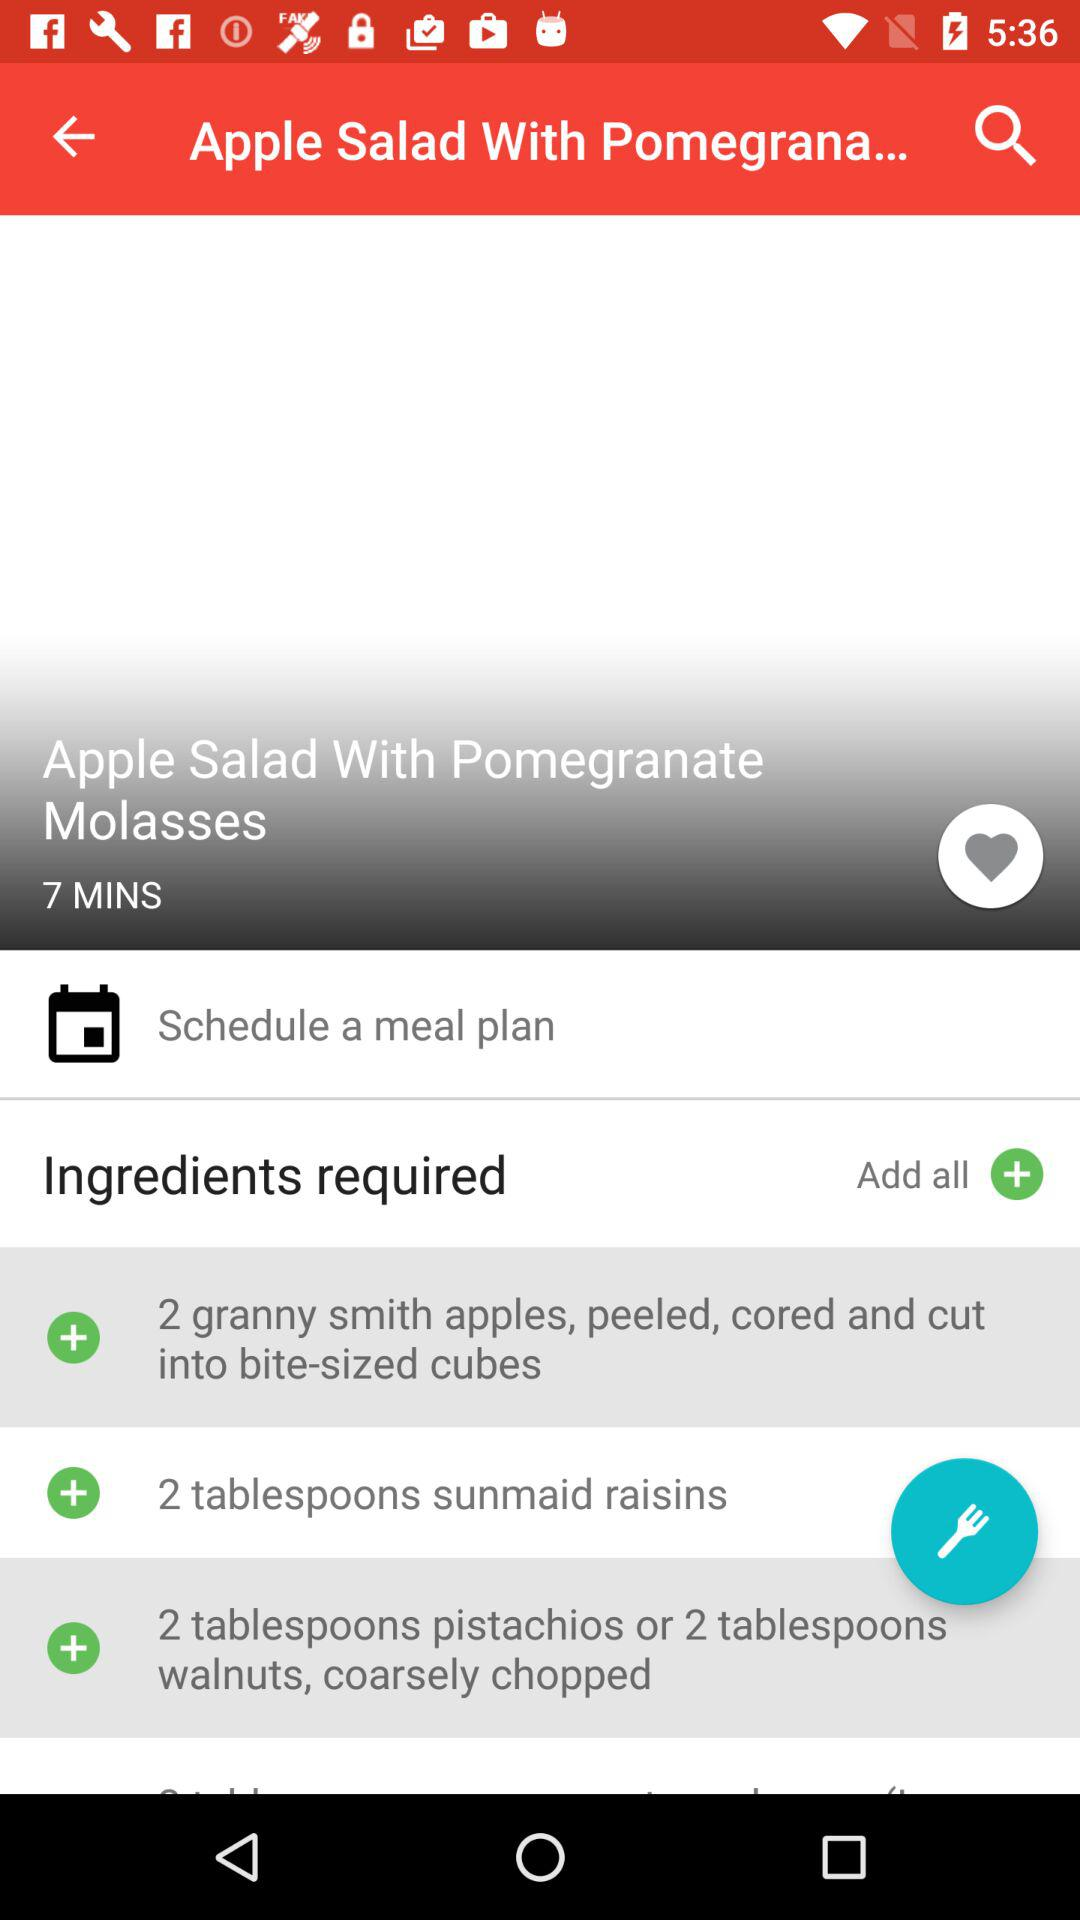How many apples are required? The required number of apples is 2. 